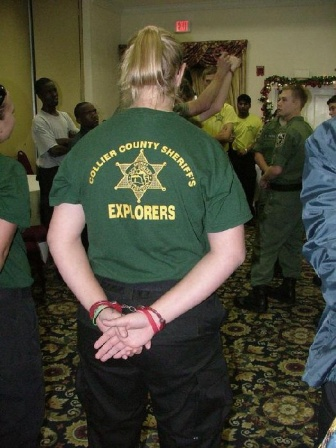If you were to write a poem inspired by this image, how would it go? In a quiet room adorned with cheer,
A figure stands, intent and clear.
Green shirt speaks of duties sworn,
A guiding light, life to adorn.
Festive tree with lights so bright,
Glimmers softly in the night.
Hands clasped firm, eyes oversee,
A moment captured, serenity.
In circle, voices rise and fall,
Unity echoes through the hall.
Amid the walls of neutral hue,
A tale unfolds, both old and new.
The season’s spirit in the air,
And wisdom’s voice, a silent prayer. 